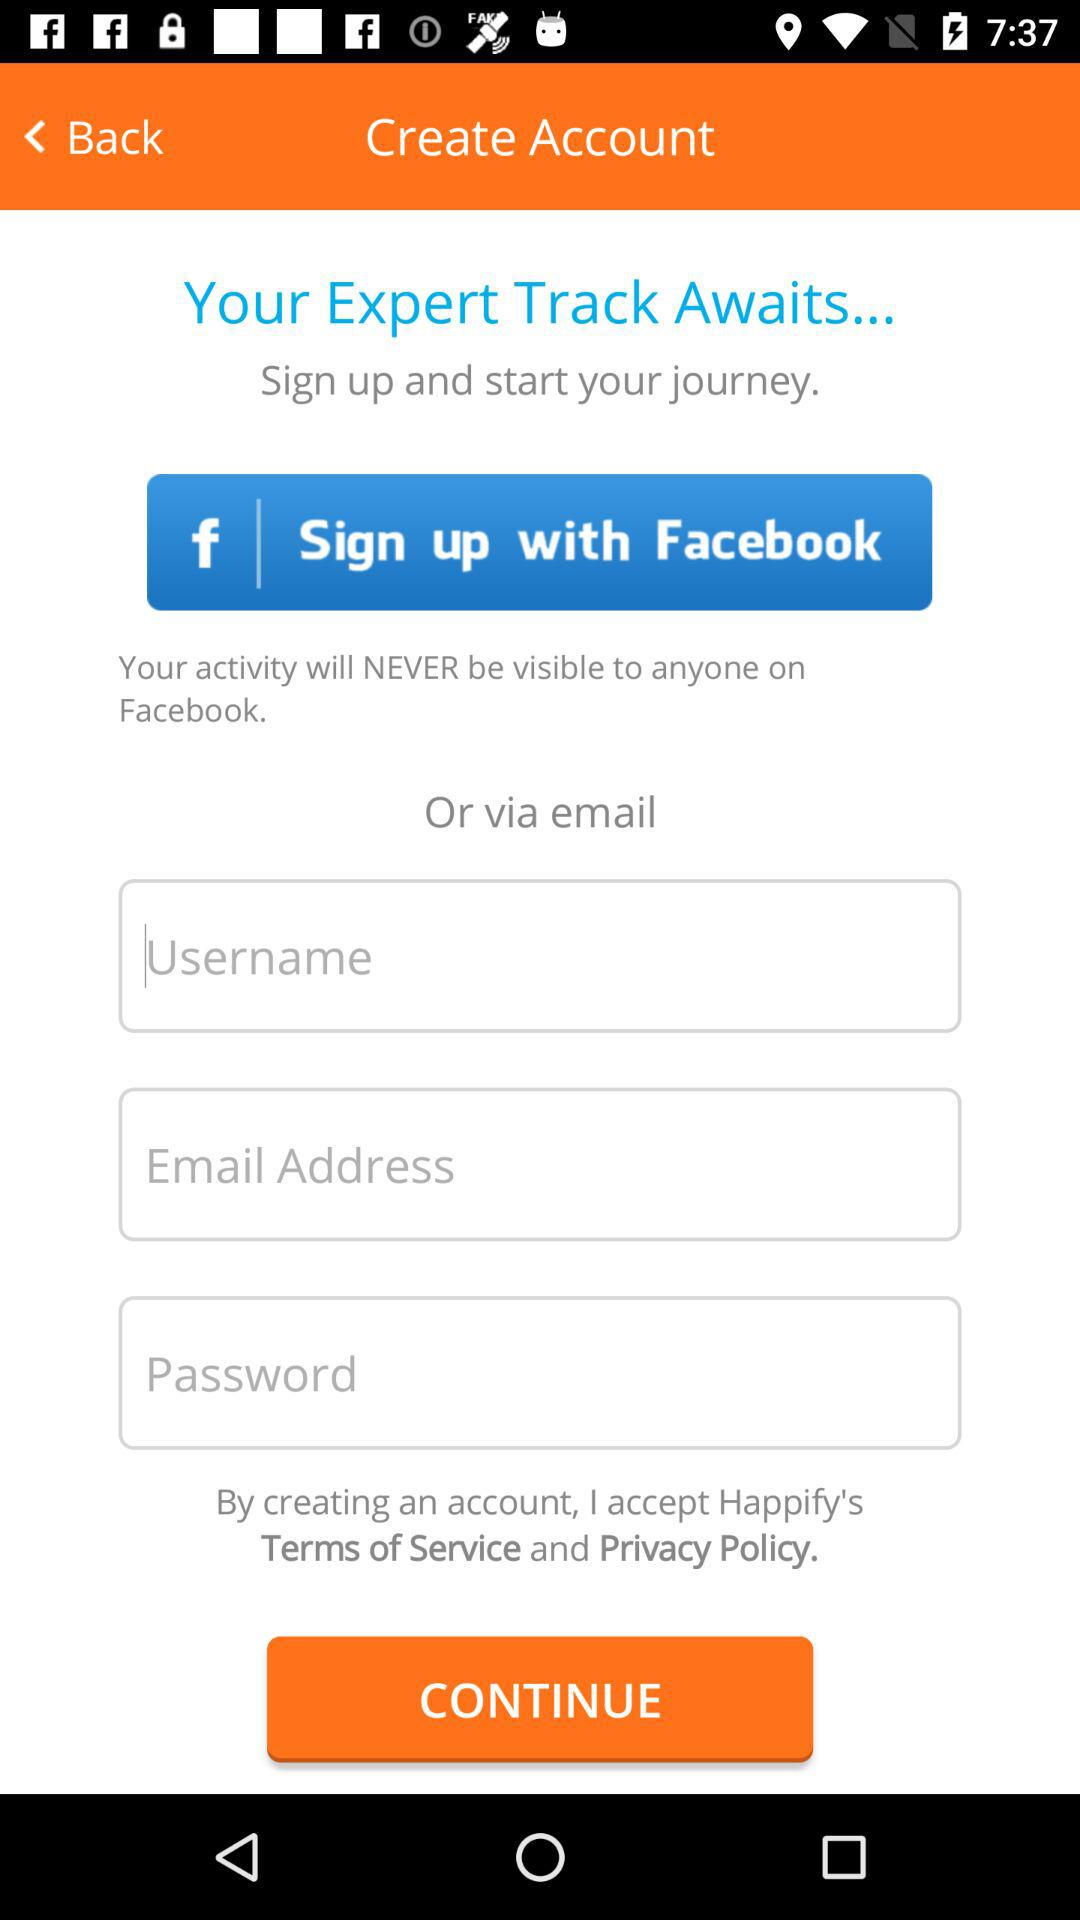What is the application name? The application name is "Facebook". 